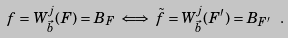<formula> <loc_0><loc_0><loc_500><loc_500>f = W _ { \vec { b } } ^ { j } ( F ) = B _ { F } \iff \tilde { f } = W _ { \vec { b } } ^ { j } ( F ^ { \prime } ) = B _ { F ^ { \prime } } \ .</formula> 